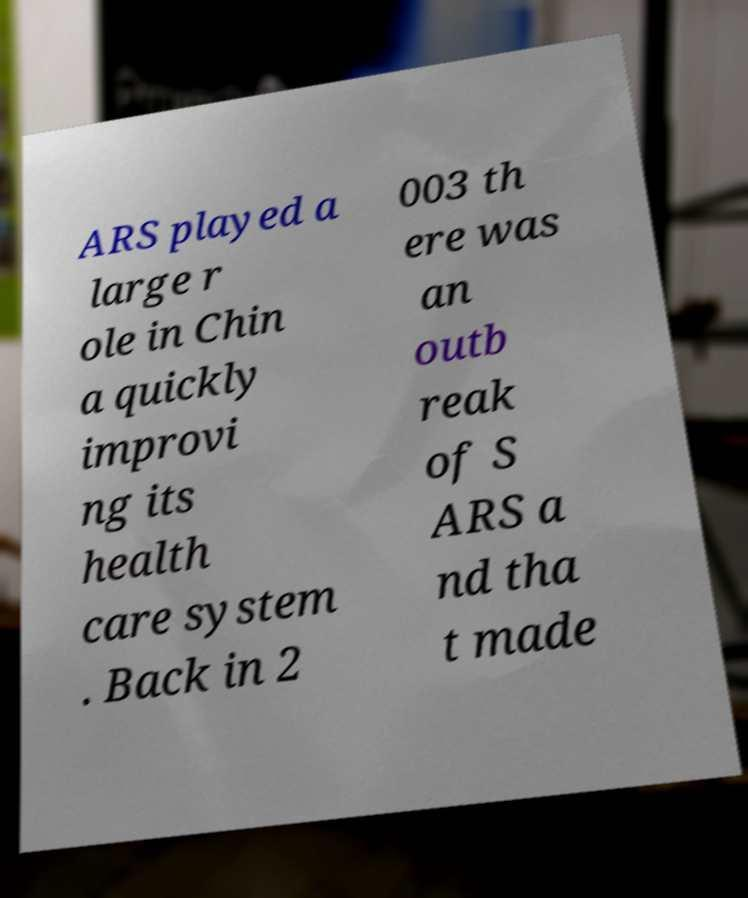There's text embedded in this image that I need extracted. Can you transcribe it verbatim? ARS played a large r ole in Chin a quickly improvi ng its health care system . Back in 2 003 th ere was an outb reak of S ARS a nd tha t made 